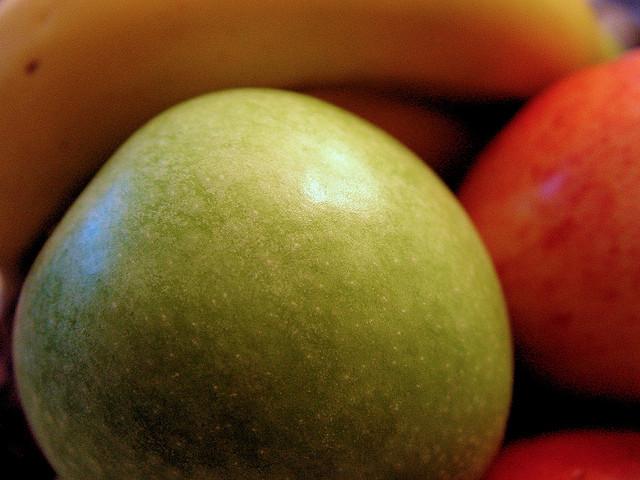Are these oranges?
Be succinct. No. What is the fruit in the background?
Short answer required. Banana. What shade of green is the apple?
Concise answer only. Light green. What fruit is this?
Write a very short answer. Apple. What type of fruit is this?
Concise answer only. Apple. What color is the fruit?
Write a very short answer. Green. How many different fruits can be seen?
Quick response, please. 3. Are both fruits pictured apples?
Keep it brief. No. What type of apples are these?
Short answer required. Granny smith. Which fruit can you peel with your hands?
Concise answer only. Banana. 